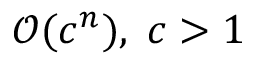Convert formula to latex. <formula><loc_0><loc_0><loc_500><loc_500>{ \mathcal { O } } ( c ^ { n } ) , \, c > 1</formula> 